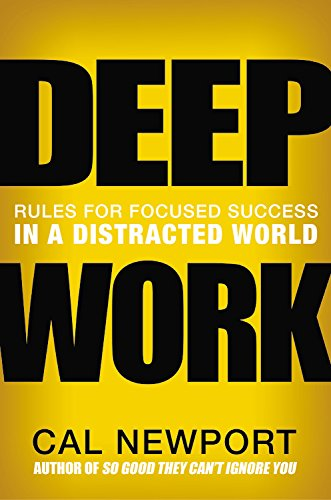What is the title of this book? The title of the book is 'Deep Work: Rules for Focused Success in a Distracted World,' suggesting an in-depth exploration of maintaining productivity in an era of constant distractions. 